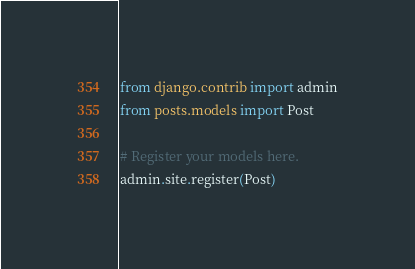Convert code to text. <code><loc_0><loc_0><loc_500><loc_500><_Python_>from django.contrib import admin
from posts.models import Post

# Register your models here.
admin.site.register(Post)</code> 